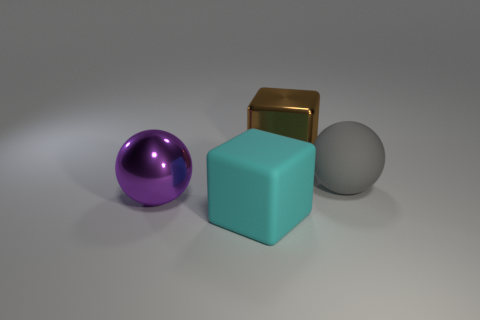How many things are behind the cyan block and in front of the big brown shiny block?
Your response must be concise. 2. How big is the shiny object that is right of the large matte thing that is in front of the big purple shiny thing?
Offer a terse response. Large. Is the number of gray objects behind the gray object less than the number of big objects that are to the right of the cyan thing?
Your response must be concise. Yes. There is a large metallic object that is left of the large brown shiny block; is its color the same as the matte thing that is in front of the large gray object?
Offer a very short reply. No. What is the thing that is right of the big purple metal ball and left of the big brown object made of?
Provide a succinct answer. Rubber. Is there a large blue shiny sphere?
Give a very brief answer. No. The other large object that is the same material as the cyan object is what shape?
Provide a succinct answer. Sphere. There is a gray thing; does it have the same shape as the matte object in front of the big gray sphere?
Make the answer very short. No. What material is the large thing in front of the sphere in front of the gray sphere?
Offer a very short reply. Rubber. How many other things are there of the same shape as the large cyan matte object?
Your response must be concise. 1. 